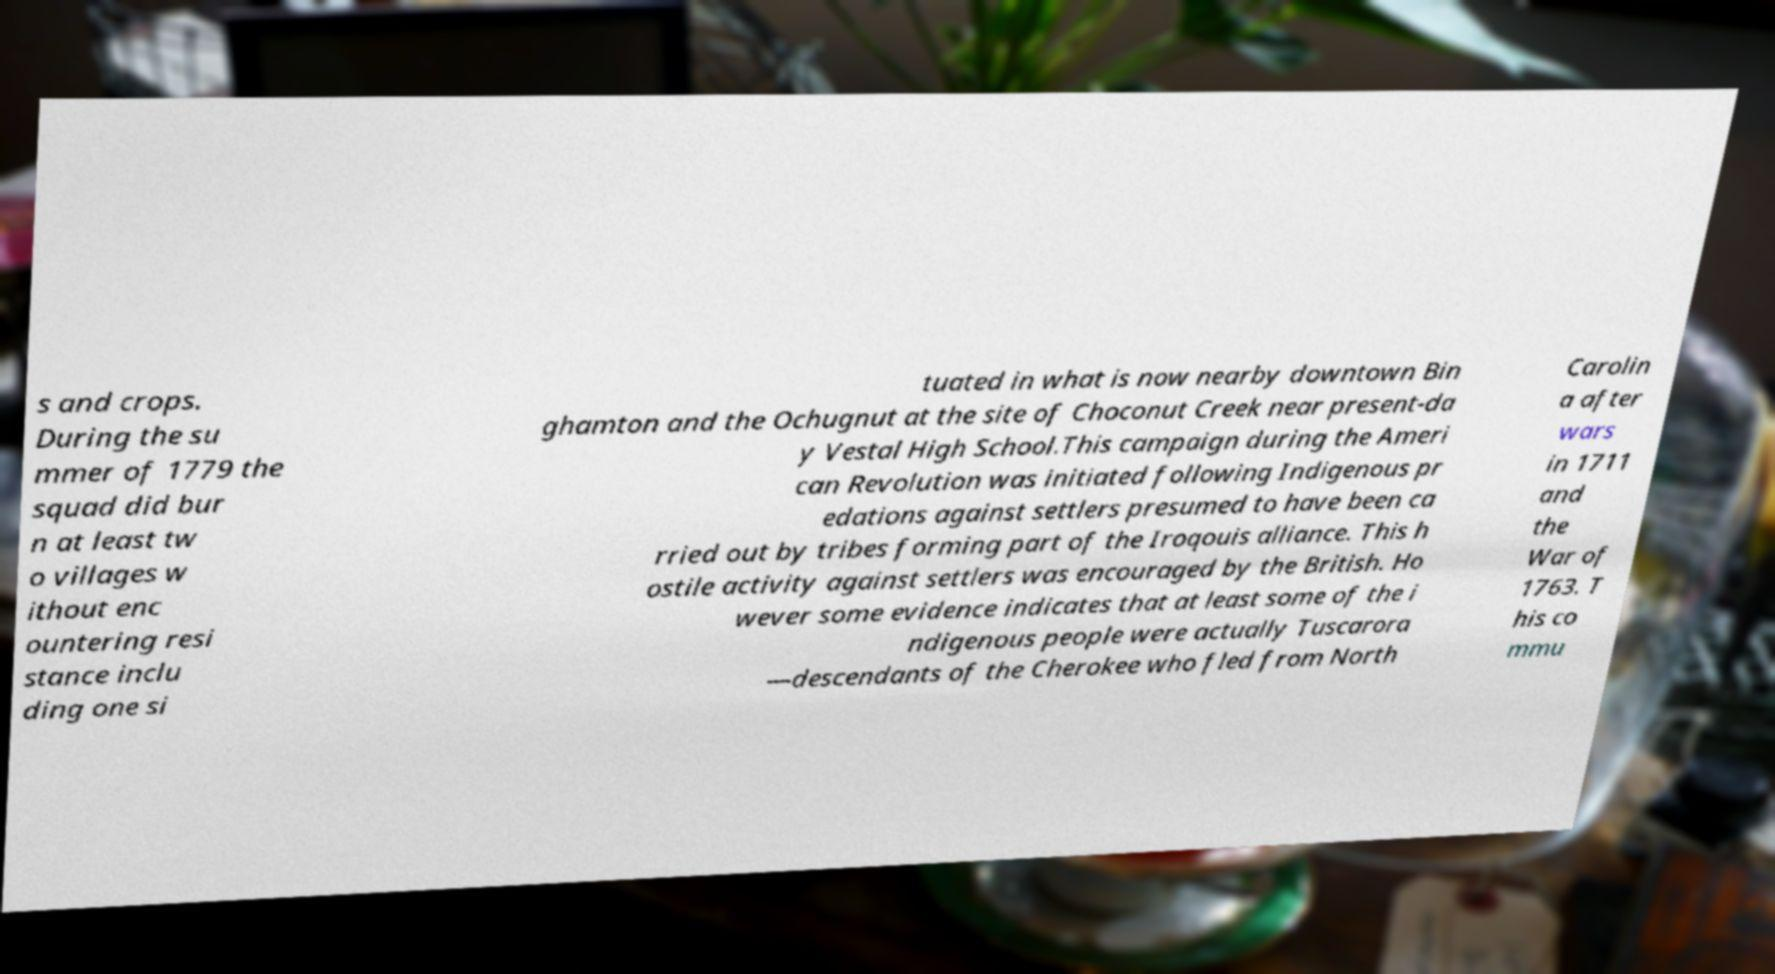Could you assist in decoding the text presented in this image and type it out clearly? s and crops. During the su mmer of 1779 the squad did bur n at least tw o villages w ithout enc ountering resi stance inclu ding one si tuated in what is now nearby downtown Bin ghamton and the Ochugnut at the site of Choconut Creek near present-da y Vestal High School.This campaign during the Ameri can Revolution was initiated following Indigenous pr edations against settlers presumed to have been ca rried out by tribes forming part of the Iroqouis alliance. This h ostile activity against settlers was encouraged by the British. Ho wever some evidence indicates that at least some of the i ndigenous people were actually Tuscarora —descendants of the Cherokee who fled from North Carolin a after wars in 1711 and the War of 1763. T his co mmu 